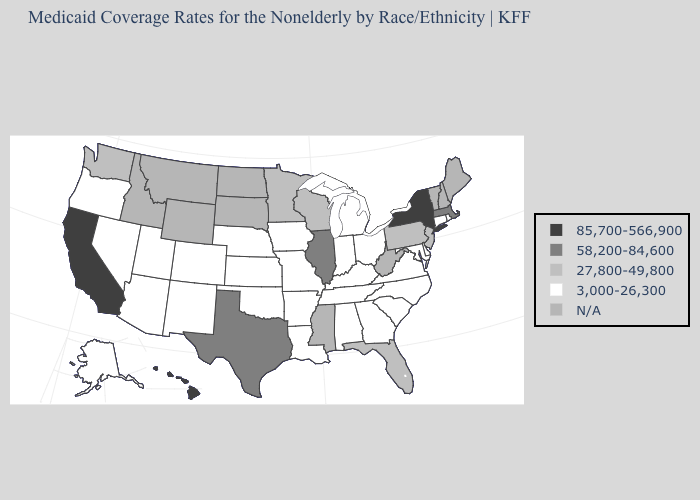Among the states that border New Jersey , which have the lowest value?
Keep it brief. Delaware. Which states have the lowest value in the USA?
Give a very brief answer. Alabama, Alaska, Arizona, Arkansas, Colorado, Connecticut, Delaware, Georgia, Indiana, Iowa, Kansas, Kentucky, Louisiana, Maryland, Michigan, Missouri, Nebraska, Nevada, New Mexico, North Carolina, Ohio, Oklahoma, Oregon, Rhode Island, South Carolina, Tennessee, Utah, Virginia. Which states have the lowest value in the West?
Write a very short answer. Alaska, Arizona, Colorado, Nevada, New Mexico, Oregon, Utah. What is the value of Illinois?
Write a very short answer. 58,200-84,600. Does Alabama have the lowest value in the USA?
Answer briefly. Yes. Does the map have missing data?
Concise answer only. Yes. Does the first symbol in the legend represent the smallest category?
Short answer required. No. Does Delaware have the lowest value in the USA?
Give a very brief answer. Yes. Does Minnesota have the lowest value in the USA?
Concise answer only. No. Among the states that border West Virginia , which have the lowest value?
Keep it brief. Kentucky, Maryland, Ohio, Virginia. What is the value of Arizona?
Concise answer only. 3,000-26,300. Which states have the highest value in the USA?
Write a very short answer. California, Hawaii, New York. What is the value of Colorado?
Answer briefly. 3,000-26,300. Among the states that border Oregon , which have the lowest value?
Write a very short answer. Nevada. 